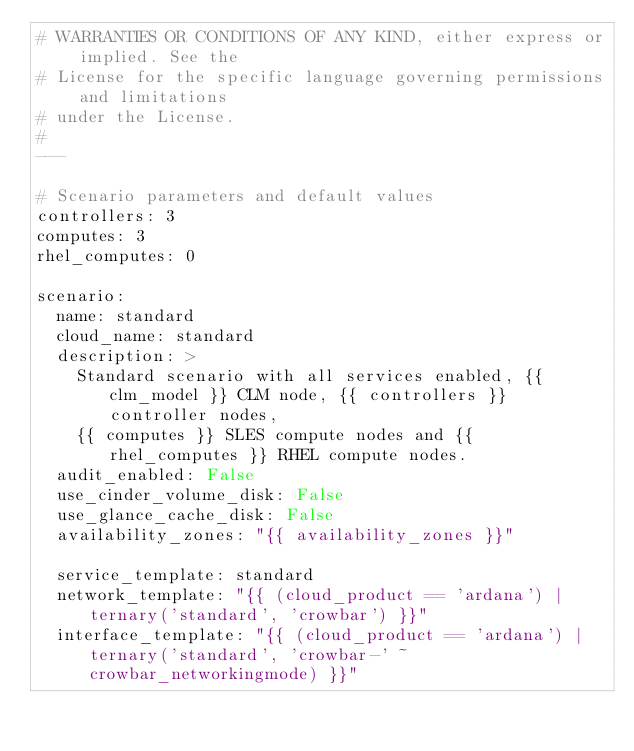<code> <loc_0><loc_0><loc_500><loc_500><_YAML_># WARRANTIES OR CONDITIONS OF ANY KIND, either express or implied. See the
# License for the specific language governing permissions and limitations
# under the License.
#
---

# Scenario parameters and default values
controllers: 3
computes: 3
rhel_computes: 0

scenario:
  name: standard
  cloud_name: standard
  description: >
    Standard scenario with all services enabled, {{ clm_model }} CLM node, {{ controllers }} controller nodes,
    {{ computes }} SLES compute nodes and {{ rhel_computes }} RHEL compute nodes.
  audit_enabled: False
  use_cinder_volume_disk: False
  use_glance_cache_disk: False
  availability_zones: "{{ availability_zones }}"

  service_template: standard
  network_template: "{{ (cloud_product == 'ardana') | ternary('standard', 'crowbar') }}"
  interface_template: "{{ (cloud_product == 'ardana') | ternary('standard', 'crowbar-' ~ crowbar_networkingmode) }}"
</code> 